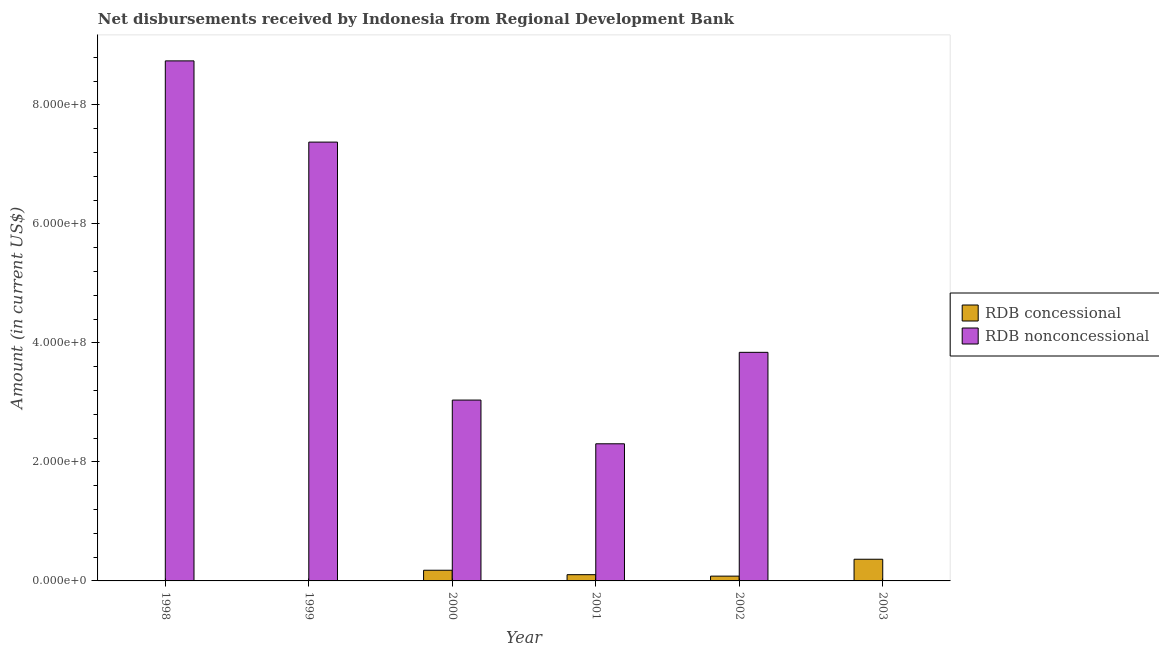How many bars are there on the 6th tick from the right?
Offer a terse response. 1. What is the label of the 6th group of bars from the left?
Provide a succinct answer. 2003. In how many cases, is the number of bars for a given year not equal to the number of legend labels?
Make the answer very short. 2. What is the net non concessional disbursements from rdb in 1999?
Offer a terse response. 7.37e+08. Across all years, what is the maximum net concessional disbursements from rdb?
Keep it short and to the point. 3.64e+07. What is the total net non concessional disbursements from rdb in the graph?
Give a very brief answer. 2.53e+09. What is the difference between the net concessional disbursements from rdb in 2001 and that in 2003?
Your answer should be compact. -2.59e+07. What is the difference between the net non concessional disbursements from rdb in 1998 and the net concessional disbursements from rdb in 1999?
Provide a succinct answer. 1.36e+08. What is the average net concessional disbursements from rdb per year?
Make the answer very short. 1.22e+07. In the year 1999, what is the difference between the net concessional disbursements from rdb and net non concessional disbursements from rdb?
Keep it short and to the point. 0. In how many years, is the net concessional disbursements from rdb greater than 320000000 US$?
Give a very brief answer. 0. What is the ratio of the net concessional disbursements from rdb in 2000 to that in 2002?
Provide a short and direct response. 2.23. Is the difference between the net concessional disbursements from rdb in 2000 and 2003 greater than the difference between the net non concessional disbursements from rdb in 2000 and 2003?
Your answer should be compact. No. What is the difference between the highest and the second highest net concessional disbursements from rdb?
Offer a very short reply. 1.85e+07. What is the difference between the highest and the lowest net non concessional disbursements from rdb?
Give a very brief answer. 8.74e+08. How many bars are there?
Your answer should be compact. 10. Are all the bars in the graph horizontal?
Your answer should be very brief. No. Are the values on the major ticks of Y-axis written in scientific E-notation?
Make the answer very short. Yes. Does the graph contain any zero values?
Make the answer very short. Yes. Does the graph contain grids?
Offer a terse response. No. How many legend labels are there?
Offer a very short reply. 2. What is the title of the graph?
Provide a short and direct response. Net disbursements received by Indonesia from Regional Development Bank. Does "GDP" appear as one of the legend labels in the graph?
Your response must be concise. No. What is the label or title of the Y-axis?
Give a very brief answer. Amount (in current US$). What is the Amount (in current US$) of RDB concessional in 1998?
Provide a succinct answer. 0. What is the Amount (in current US$) in RDB nonconcessional in 1998?
Your response must be concise. 8.74e+08. What is the Amount (in current US$) of RDB concessional in 1999?
Provide a succinct answer. 5.38e+05. What is the Amount (in current US$) of RDB nonconcessional in 1999?
Ensure brevity in your answer.  7.37e+08. What is the Amount (in current US$) of RDB concessional in 2000?
Your answer should be very brief. 1.79e+07. What is the Amount (in current US$) of RDB nonconcessional in 2000?
Offer a very short reply. 3.04e+08. What is the Amount (in current US$) in RDB concessional in 2001?
Provide a succinct answer. 1.05e+07. What is the Amount (in current US$) of RDB nonconcessional in 2001?
Provide a short and direct response. 2.30e+08. What is the Amount (in current US$) of RDB concessional in 2002?
Keep it short and to the point. 8.04e+06. What is the Amount (in current US$) of RDB nonconcessional in 2002?
Make the answer very short. 3.84e+08. What is the Amount (in current US$) in RDB concessional in 2003?
Give a very brief answer. 3.64e+07. What is the Amount (in current US$) in RDB nonconcessional in 2003?
Keep it short and to the point. 0. Across all years, what is the maximum Amount (in current US$) in RDB concessional?
Make the answer very short. 3.64e+07. Across all years, what is the maximum Amount (in current US$) of RDB nonconcessional?
Provide a succinct answer. 8.74e+08. What is the total Amount (in current US$) of RDB concessional in the graph?
Offer a terse response. 7.34e+07. What is the total Amount (in current US$) in RDB nonconcessional in the graph?
Your answer should be very brief. 2.53e+09. What is the difference between the Amount (in current US$) of RDB nonconcessional in 1998 and that in 1999?
Your answer should be compact. 1.36e+08. What is the difference between the Amount (in current US$) of RDB nonconcessional in 1998 and that in 2000?
Offer a terse response. 5.70e+08. What is the difference between the Amount (in current US$) of RDB nonconcessional in 1998 and that in 2001?
Make the answer very short. 6.43e+08. What is the difference between the Amount (in current US$) in RDB nonconcessional in 1998 and that in 2002?
Your response must be concise. 4.90e+08. What is the difference between the Amount (in current US$) of RDB concessional in 1999 and that in 2000?
Offer a very short reply. -1.74e+07. What is the difference between the Amount (in current US$) in RDB nonconcessional in 1999 and that in 2000?
Ensure brevity in your answer.  4.34e+08. What is the difference between the Amount (in current US$) in RDB concessional in 1999 and that in 2001?
Your answer should be very brief. -9.96e+06. What is the difference between the Amount (in current US$) in RDB nonconcessional in 1999 and that in 2001?
Your answer should be very brief. 5.07e+08. What is the difference between the Amount (in current US$) of RDB concessional in 1999 and that in 2002?
Provide a short and direct response. -7.51e+06. What is the difference between the Amount (in current US$) of RDB nonconcessional in 1999 and that in 2002?
Your answer should be compact. 3.53e+08. What is the difference between the Amount (in current US$) in RDB concessional in 1999 and that in 2003?
Keep it short and to the point. -3.59e+07. What is the difference between the Amount (in current US$) in RDB concessional in 2000 and that in 2001?
Your response must be concise. 7.44e+06. What is the difference between the Amount (in current US$) in RDB nonconcessional in 2000 and that in 2001?
Provide a short and direct response. 7.35e+07. What is the difference between the Amount (in current US$) in RDB concessional in 2000 and that in 2002?
Your answer should be compact. 9.89e+06. What is the difference between the Amount (in current US$) in RDB nonconcessional in 2000 and that in 2002?
Provide a succinct answer. -8.02e+07. What is the difference between the Amount (in current US$) in RDB concessional in 2000 and that in 2003?
Offer a terse response. -1.85e+07. What is the difference between the Amount (in current US$) in RDB concessional in 2001 and that in 2002?
Offer a very short reply. 2.45e+06. What is the difference between the Amount (in current US$) in RDB nonconcessional in 2001 and that in 2002?
Your answer should be compact. -1.54e+08. What is the difference between the Amount (in current US$) in RDB concessional in 2001 and that in 2003?
Provide a succinct answer. -2.59e+07. What is the difference between the Amount (in current US$) of RDB concessional in 2002 and that in 2003?
Your response must be concise. -2.84e+07. What is the difference between the Amount (in current US$) in RDB concessional in 1999 and the Amount (in current US$) in RDB nonconcessional in 2000?
Make the answer very short. -3.03e+08. What is the difference between the Amount (in current US$) of RDB concessional in 1999 and the Amount (in current US$) of RDB nonconcessional in 2001?
Keep it short and to the point. -2.30e+08. What is the difference between the Amount (in current US$) in RDB concessional in 1999 and the Amount (in current US$) in RDB nonconcessional in 2002?
Ensure brevity in your answer.  -3.84e+08. What is the difference between the Amount (in current US$) of RDB concessional in 2000 and the Amount (in current US$) of RDB nonconcessional in 2001?
Your answer should be very brief. -2.12e+08. What is the difference between the Amount (in current US$) of RDB concessional in 2000 and the Amount (in current US$) of RDB nonconcessional in 2002?
Offer a terse response. -3.66e+08. What is the difference between the Amount (in current US$) in RDB concessional in 2001 and the Amount (in current US$) in RDB nonconcessional in 2002?
Give a very brief answer. -3.74e+08. What is the average Amount (in current US$) of RDB concessional per year?
Provide a short and direct response. 1.22e+07. What is the average Amount (in current US$) in RDB nonconcessional per year?
Keep it short and to the point. 4.22e+08. In the year 1999, what is the difference between the Amount (in current US$) of RDB concessional and Amount (in current US$) of RDB nonconcessional?
Your response must be concise. -7.37e+08. In the year 2000, what is the difference between the Amount (in current US$) of RDB concessional and Amount (in current US$) of RDB nonconcessional?
Your response must be concise. -2.86e+08. In the year 2001, what is the difference between the Amount (in current US$) of RDB concessional and Amount (in current US$) of RDB nonconcessional?
Your answer should be compact. -2.20e+08. In the year 2002, what is the difference between the Amount (in current US$) in RDB concessional and Amount (in current US$) in RDB nonconcessional?
Keep it short and to the point. -3.76e+08. What is the ratio of the Amount (in current US$) in RDB nonconcessional in 1998 to that in 1999?
Ensure brevity in your answer.  1.19. What is the ratio of the Amount (in current US$) in RDB nonconcessional in 1998 to that in 2000?
Your response must be concise. 2.88. What is the ratio of the Amount (in current US$) of RDB nonconcessional in 1998 to that in 2001?
Offer a very short reply. 3.79. What is the ratio of the Amount (in current US$) in RDB nonconcessional in 1998 to that in 2002?
Your answer should be very brief. 2.28. What is the ratio of the Amount (in current US$) of RDB nonconcessional in 1999 to that in 2000?
Offer a very short reply. 2.43. What is the ratio of the Amount (in current US$) of RDB concessional in 1999 to that in 2001?
Your answer should be compact. 0.05. What is the ratio of the Amount (in current US$) of RDB nonconcessional in 1999 to that in 2001?
Give a very brief answer. 3.2. What is the ratio of the Amount (in current US$) of RDB concessional in 1999 to that in 2002?
Provide a short and direct response. 0.07. What is the ratio of the Amount (in current US$) in RDB nonconcessional in 1999 to that in 2002?
Provide a short and direct response. 1.92. What is the ratio of the Amount (in current US$) of RDB concessional in 1999 to that in 2003?
Make the answer very short. 0.01. What is the ratio of the Amount (in current US$) in RDB concessional in 2000 to that in 2001?
Offer a very short reply. 1.71. What is the ratio of the Amount (in current US$) of RDB nonconcessional in 2000 to that in 2001?
Make the answer very short. 1.32. What is the ratio of the Amount (in current US$) of RDB concessional in 2000 to that in 2002?
Keep it short and to the point. 2.23. What is the ratio of the Amount (in current US$) of RDB nonconcessional in 2000 to that in 2002?
Make the answer very short. 0.79. What is the ratio of the Amount (in current US$) in RDB concessional in 2000 to that in 2003?
Give a very brief answer. 0.49. What is the ratio of the Amount (in current US$) in RDB concessional in 2001 to that in 2002?
Provide a short and direct response. 1.3. What is the ratio of the Amount (in current US$) of RDB nonconcessional in 2001 to that in 2002?
Give a very brief answer. 0.6. What is the ratio of the Amount (in current US$) of RDB concessional in 2001 to that in 2003?
Your answer should be compact. 0.29. What is the ratio of the Amount (in current US$) of RDB concessional in 2002 to that in 2003?
Make the answer very short. 0.22. What is the difference between the highest and the second highest Amount (in current US$) of RDB concessional?
Ensure brevity in your answer.  1.85e+07. What is the difference between the highest and the second highest Amount (in current US$) in RDB nonconcessional?
Offer a terse response. 1.36e+08. What is the difference between the highest and the lowest Amount (in current US$) in RDB concessional?
Ensure brevity in your answer.  3.64e+07. What is the difference between the highest and the lowest Amount (in current US$) in RDB nonconcessional?
Ensure brevity in your answer.  8.74e+08. 